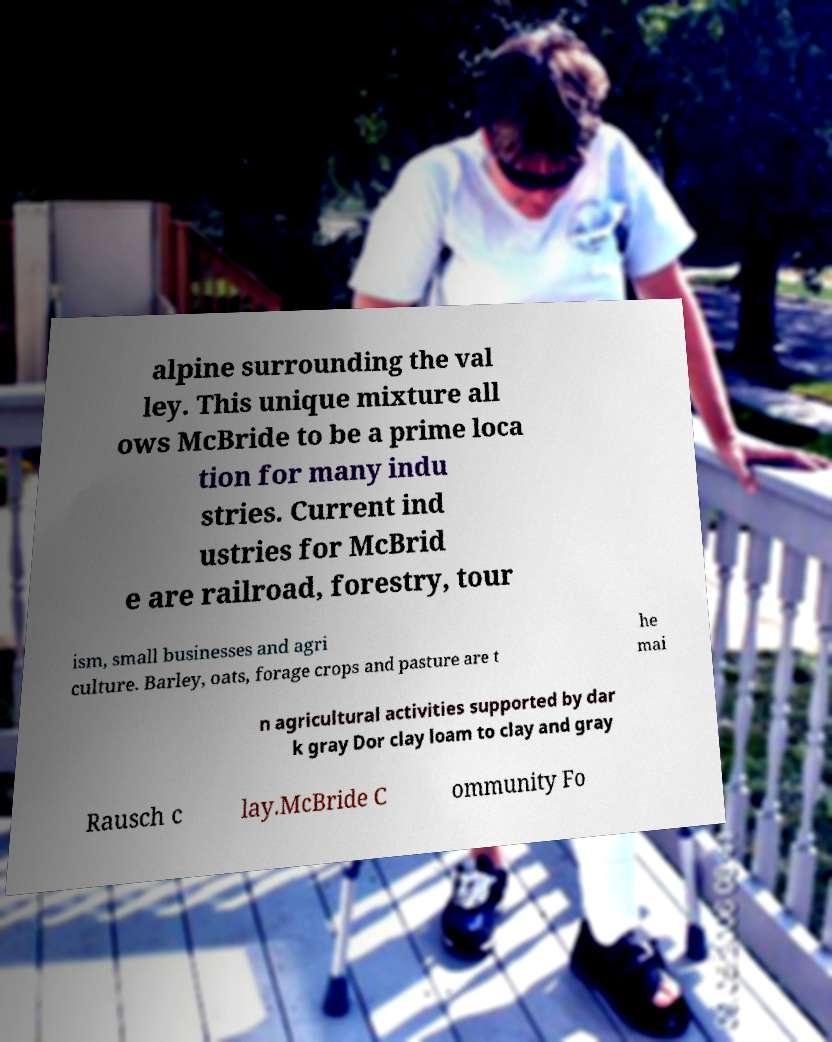Please read and relay the text visible in this image. What does it say? alpine surrounding the val ley. This unique mixture all ows McBride to be a prime loca tion for many indu stries. Current ind ustries for McBrid e are railroad, forestry, tour ism, small businesses and agri culture. Barley, oats, forage crops and pasture are t he mai n agricultural activities supported by dar k gray Dor clay loam to clay and gray Rausch c lay.McBride C ommunity Fo 